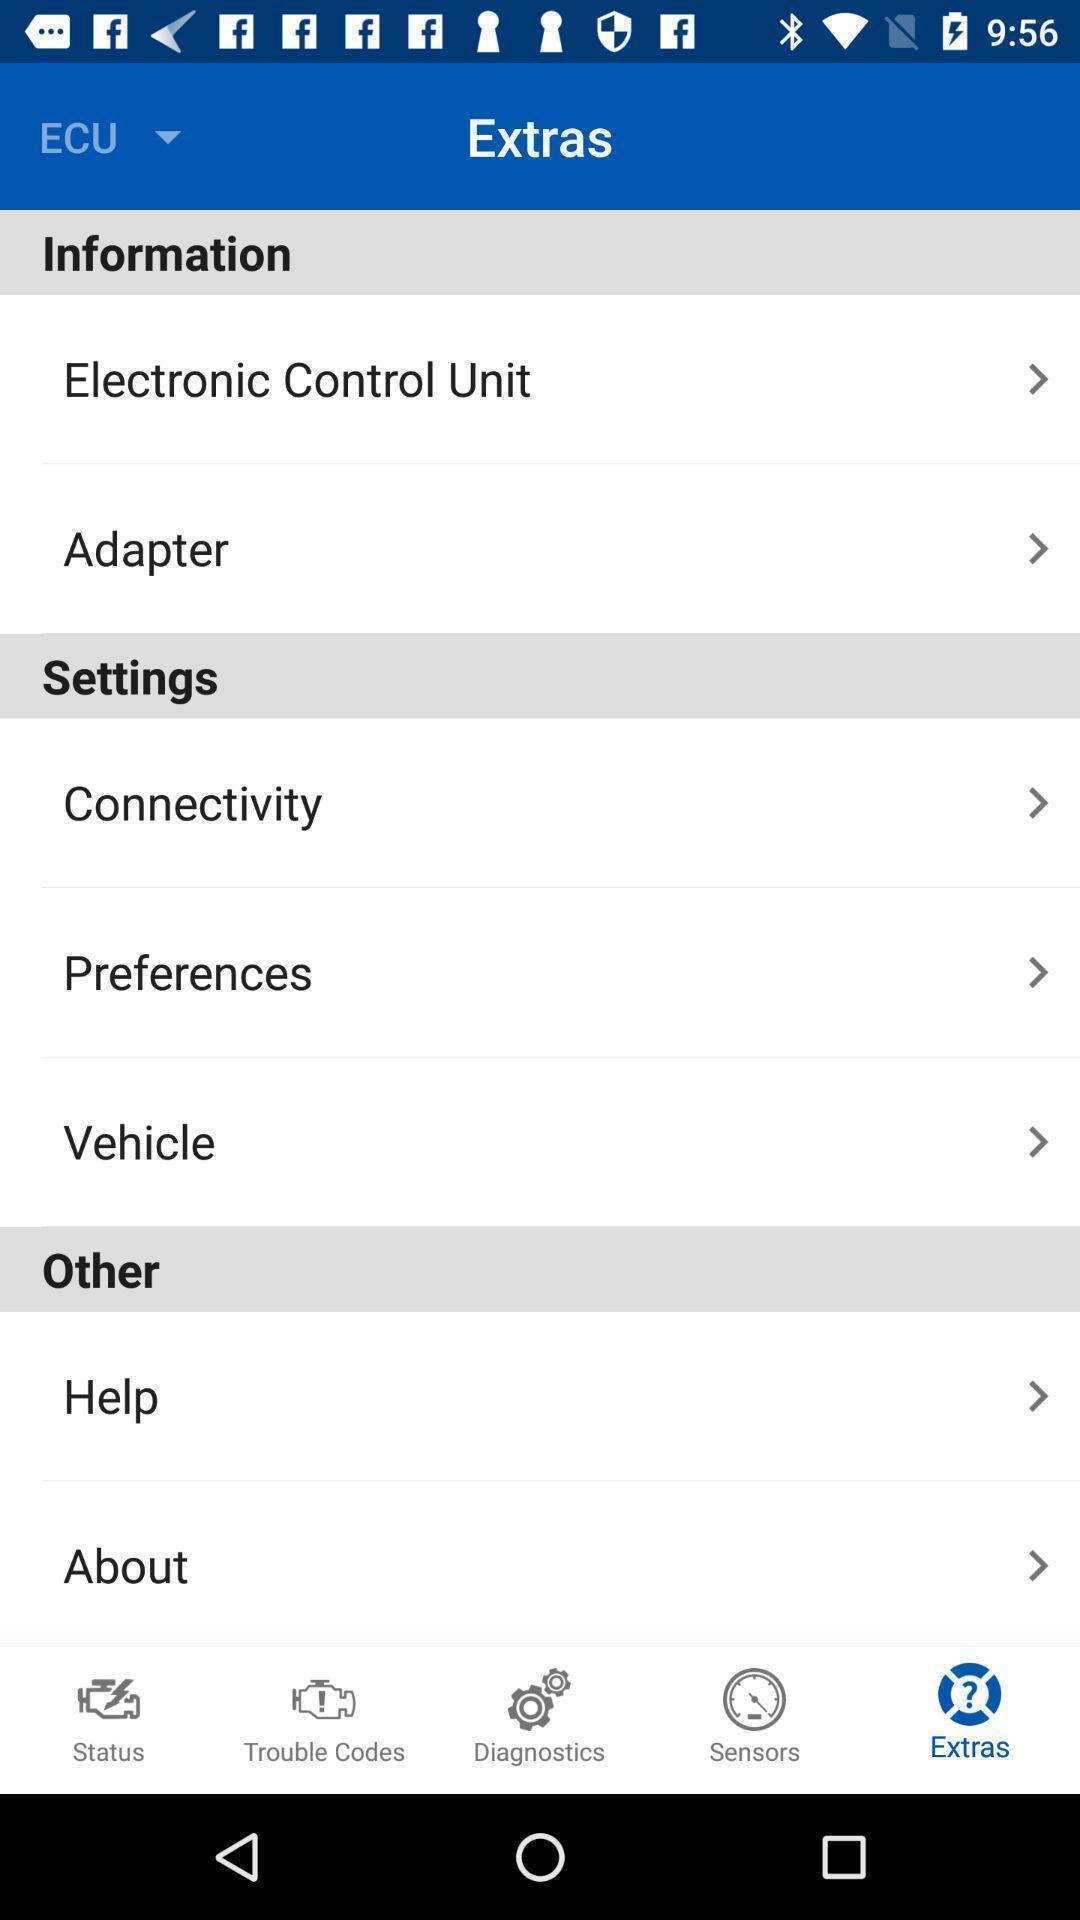Summarize the main components in this picture. Page showing list of options in extras. 